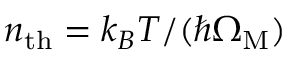Convert formula to latex. <formula><loc_0><loc_0><loc_500><loc_500>n _ { t h } = k _ { B } T / ( \hbar { \Omega } _ { M } )</formula> 